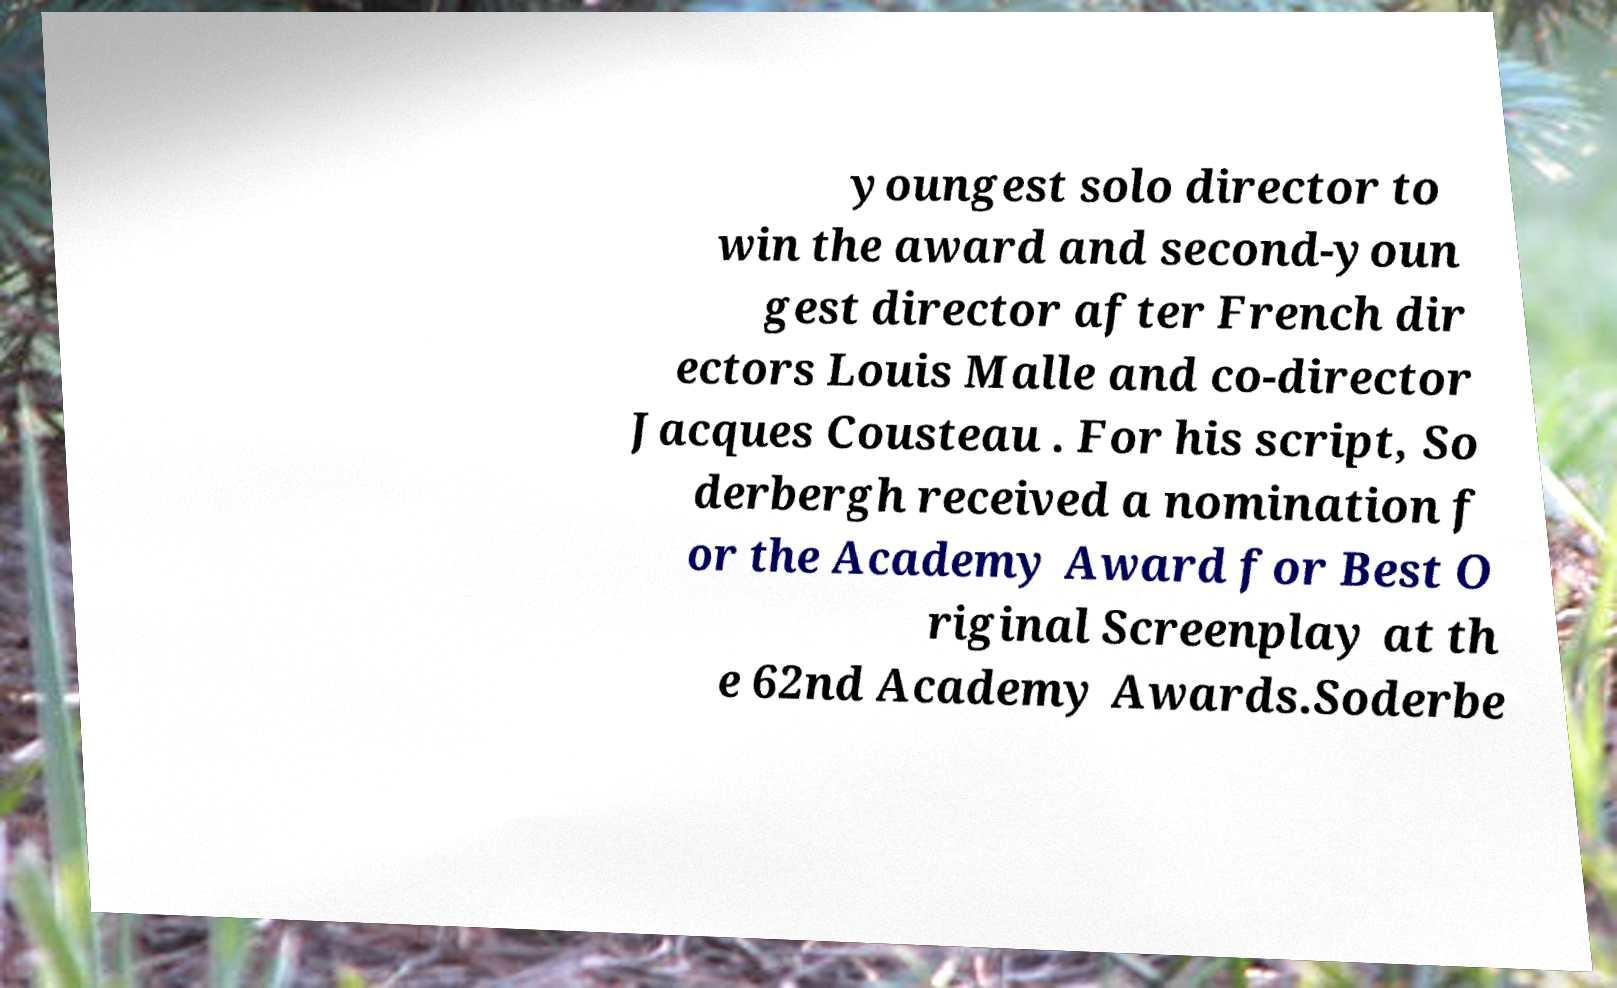Could you assist in decoding the text presented in this image and type it out clearly? youngest solo director to win the award and second-youn gest director after French dir ectors Louis Malle and co-director Jacques Cousteau . For his script, So derbergh received a nomination f or the Academy Award for Best O riginal Screenplay at th e 62nd Academy Awards.Soderbe 